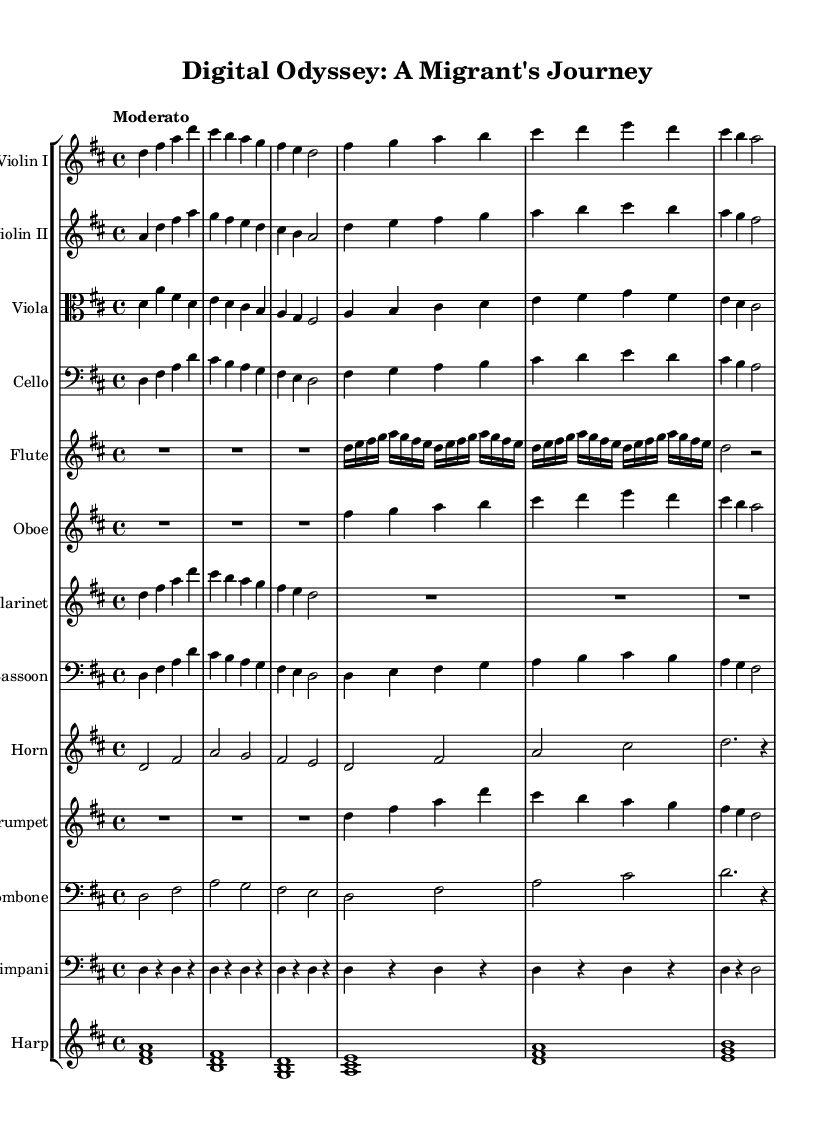What is the key signature of this music? The key signature is indicated at the beginning of the score, showing two sharps, which represent F# and C#. This is characteristic of D major.
Answer: D major What is the time signature of this music? The time signature is found at the beginning of the score, indicated as 4/4. This means there are four beats in a measure, and the quarter note gets one beat.
Answer: 4/4 What is the tempo marking of this music? The tempo is described at the beginning of the score, where it is marked "Moderato," indicating a moderate speed.
Answer: Moderato How many different instruments are present in the score? By counting the number of staffs in the score, each representing a different instrument, we find a total of twelve instruments listed.
Answer: Twelve Which instruments play the same melodic line at the beginning? Looking at the first measures, the Violin I and Violin II play the same melodic notes swirling around D, bouncing between F# and A, creating a harmonic foundation.
Answer: Violin I and Violin II What is the significance of the harp in this symphony? The harp provides a unique texture by playing arpeggiated chords, which is a typical feature in symphonic compositions for creating a flowing sound, complementing the strings and woodwinds.
Answer: Unique texture How many measures does the flute take a rest at the beginning? The flute has a rest for three whole beats at the beginning of the score, indicated by the notation R1*3.
Answer: Three 